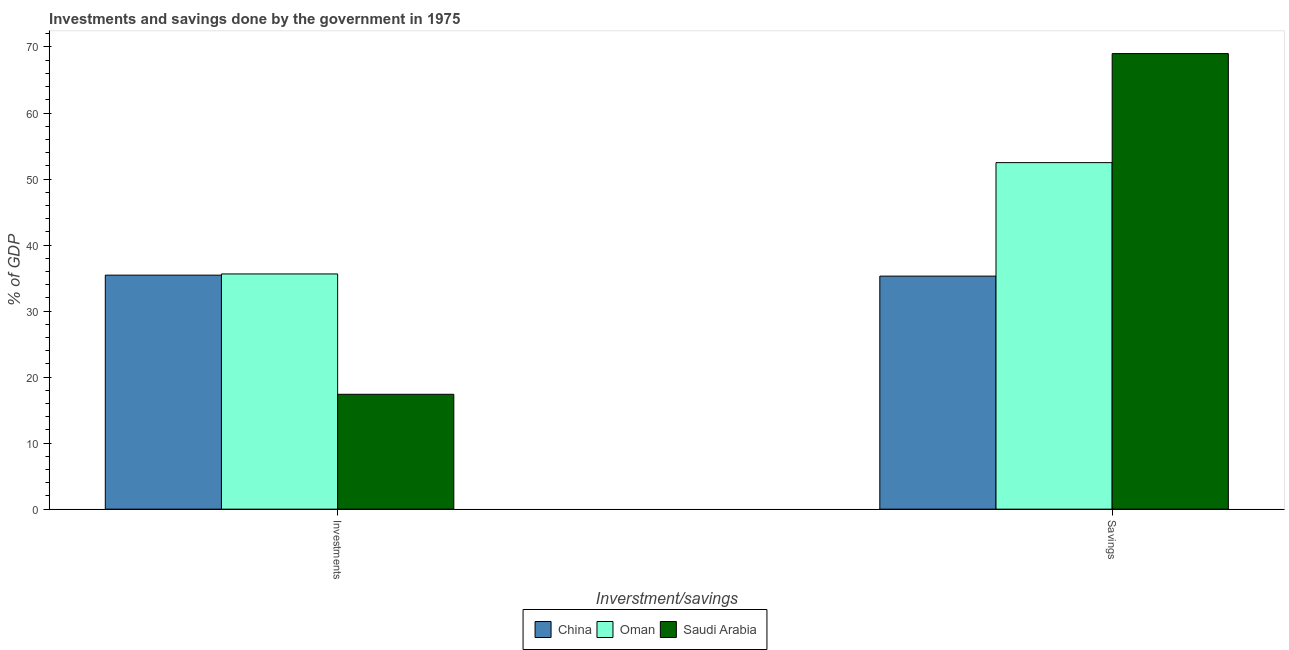Are the number of bars per tick equal to the number of legend labels?
Keep it short and to the point. Yes. How many bars are there on the 2nd tick from the right?
Keep it short and to the point. 3. What is the label of the 2nd group of bars from the left?
Give a very brief answer. Savings. What is the savings of government in China?
Give a very brief answer. 35.3. Across all countries, what is the maximum investments of government?
Keep it short and to the point. 35.63. Across all countries, what is the minimum investments of government?
Your response must be concise. 17.4. In which country was the investments of government maximum?
Give a very brief answer. Oman. In which country was the investments of government minimum?
Keep it short and to the point. Saudi Arabia. What is the total investments of government in the graph?
Provide a succinct answer. 88.47. What is the difference between the savings of government in Oman and that in Saudi Arabia?
Give a very brief answer. -16.51. What is the difference between the savings of government in Oman and the investments of government in Saudi Arabia?
Make the answer very short. 35.09. What is the average investments of government per country?
Make the answer very short. 29.49. What is the difference between the savings of government and investments of government in Oman?
Provide a succinct answer. 16.86. What is the ratio of the savings of government in China to that in Saudi Arabia?
Offer a terse response. 0.51. Is the savings of government in Oman less than that in China?
Offer a very short reply. No. What does the 2nd bar from the left in Investments represents?
Your response must be concise. Oman. What does the 1st bar from the right in Savings represents?
Provide a short and direct response. Saudi Arabia. How many bars are there?
Offer a very short reply. 6. Are all the bars in the graph horizontal?
Ensure brevity in your answer.  No. Does the graph contain any zero values?
Your answer should be very brief. No. Does the graph contain grids?
Offer a very short reply. No. How many legend labels are there?
Offer a very short reply. 3. How are the legend labels stacked?
Your answer should be very brief. Horizontal. What is the title of the graph?
Offer a very short reply. Investments and savings done by the government in 1975. Does "High income" appear as one of the legend labels in the graph?
Your answer should be compact. No. What is the label or title of the X-axis?
Provide a succinct answer. Inverstment/savings. What is the label or title of the Y-axis?
Give a very brief answer. % of GDP. What is the % of GDP of China in Investments?
Make the answer very short. 35.44. What is the % of GDP of Oman in Investments?
Offer a very short reply. 35.63. What is the % of GDP in Saudi Arabia in Investments?
Keep it short and to the point. 17.4. What is the % of GDP of China in Savings?
Your answer should be compact. 35.3. What is the % of GDP of Oman in Savings?
Your response must be concise. 52.49. What is the % of GDP in Saudi Arabia in Savings?
Ensure brevity in your answer.  69. Across all Inverstment/savings, what is the maximum % of GDP of China?
Offer a very short reply. 35.44. Across all Inverstment/savings, what is the maximum % of GDP of Oman?
Keep it short and to the point. 52.49. Across all Inverstment/savings, what is the maximum % of GDP in Saudi Arabia?
Your response must be concise. 69. Across all Inverstment/savings, what is the minimum % of GDP in China?
Provide a short and direct response. 35.3. Across all Inverstment/savings, what is the minimum % of GDP in Oman?
Ensure brevity in your answer.  35.63. Across all Inverstment/savings, what is the minimum % of GDP of Saudi Arabia?
Provide a succinct answer. 17.4. What is the total % of GDP of China in the graph?
Keep it short and to the point. 70.74. What is the total % of GDP of Oman in the graph?
Your answer should be very brief. 88.11. What is the total % of GDP in Saudi Arabia in the graph?
Make the answer very short. 86.4. What is the difference between the % of GDP of China in Investments and that in Savings?
Keep it short and to the point. 0.15. What is the difference between the % of GDP of Oman in Investments and that in Savings?
Your response must be concise. -16.86. What is the difference between the % of GDP in Saudi Arabia in Investments and that in Savings?
Give a very brief answer. -51.6. What is the difference between the % of GDP in China in Investments and the % of GDP in Oman in Savings?
Provide a short and direct response. -17.04. What is the difference between the % of GDP of China in Investments and the % of GDP of Saudi Arabia in Savings?
Make the answer very short. -33.56. What is the difference between the % of GDP in Oman in Investments and the % of GDP in Saudi Arabia in Savings?
Offer a very short reply. -33.37. What is the average % of GDP in China per Inverstment/savings?
Your response must be concise. 35.37. What is the average % of GDP in Oman per Inverstment/savings?
Offer a very short reply. 44.06. What is the average % of GDP of Saudi Arabia per Inverstment/savings?
Offer a very short reply. 43.2. What is the difference between the % of GDP in China and % of GDP in Oman in Investments?
Your response must be concise. -0.18. What is the difference between the % of GDP in China and % of GDP in Saudi Arabia in Investments?
Give a very brief answer. 18.04. What is the difference between the % of GDP in Oman and % of GDP in Saudi Arabia in Investments?
Offer a terse response. 18.23. What is the difference between the % of GDP in China and % of GDP in Oman in Savings?
Keep it short and to the point. -17.19. What is the difference between the % of GDP in China and % of GDP in Saudi Arabia in Savings?
Your response must be concise. -33.7. What is the difference between the % of GDP in Oman and % of GDP in Saudi Arabia in Savings?
Your answer should be very brief. -16.51. What is the ratio of the % of GDP in China in Investments to that in Savings?
Ensure brevity in your answer.  1. What is the ratio of the % of GDP of Oman in Investments to that in Savings?
Offer a terse response. 0.68. What is the ratio of the % of GDP in Saudi Arabia in Investments to that in Savings?
Give a very brief answer. 0.25. What is the difference between the highest and the second highest % of GDP of China?
Give a very brief answer. 0.15. What is the difference between the highest and the second highest % of GDP of Oman?
Provide a short and direct response. 16.86. What is the difference between the highest and the second highest % of GDP of Saudi Arabia?
Offer a very short reply. 51.6. What is the difference between the highest and the lowest % of GDP in China?
Your response must be concise. 0.15. What is the difference between the highest and the lowest % of GDP of Oman?
Provide a succinct answer. 16.86. What is the difference between the highest and the lowest % of GDP in Saudi Arabia?
Provide a short and direct response. 51.6. 